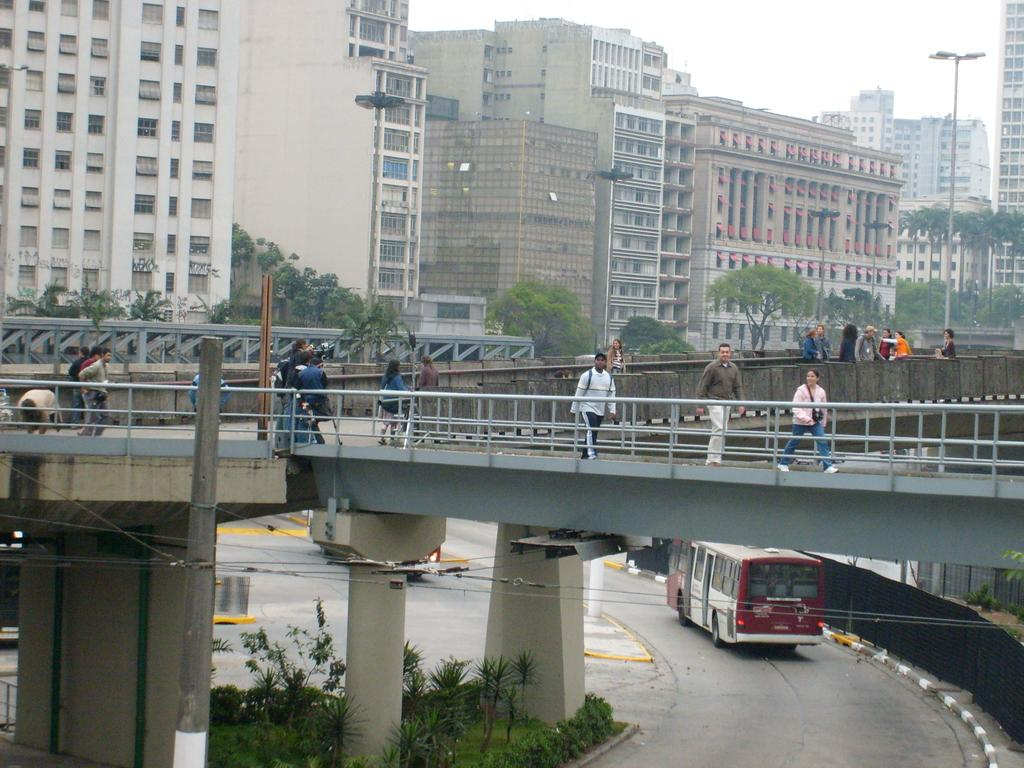What type of vehicle is on the road in the image? There is a bus on the road in the image. What architectural features can be seen in the image? There are pillars, buildings, and poles in the image. What type of vegetation is present in the image? There are trees in the image. What are the people in the image doing? The people are walking on a bridge in the image. What part of the natural environment is visible in the image? The sky is visible in the background of the image. What type of judge can be seen talking to the ducks in the image? There is no judge or ducks present in the image. 